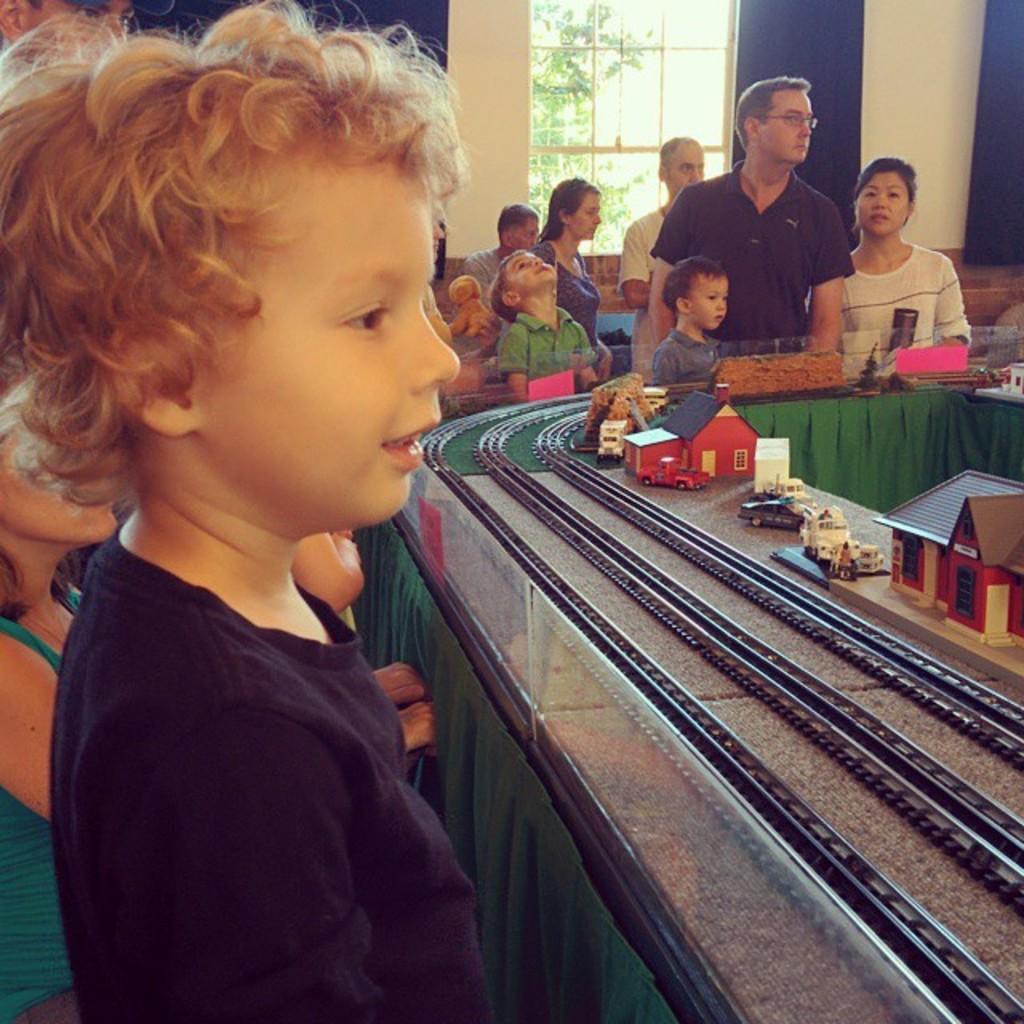How would you summarize this image in a sentence or two? In this image there are group of people standing , there are toy houses, toy railway tracks and toy vehicles on the table, and in the background there is wall, window, tree. 